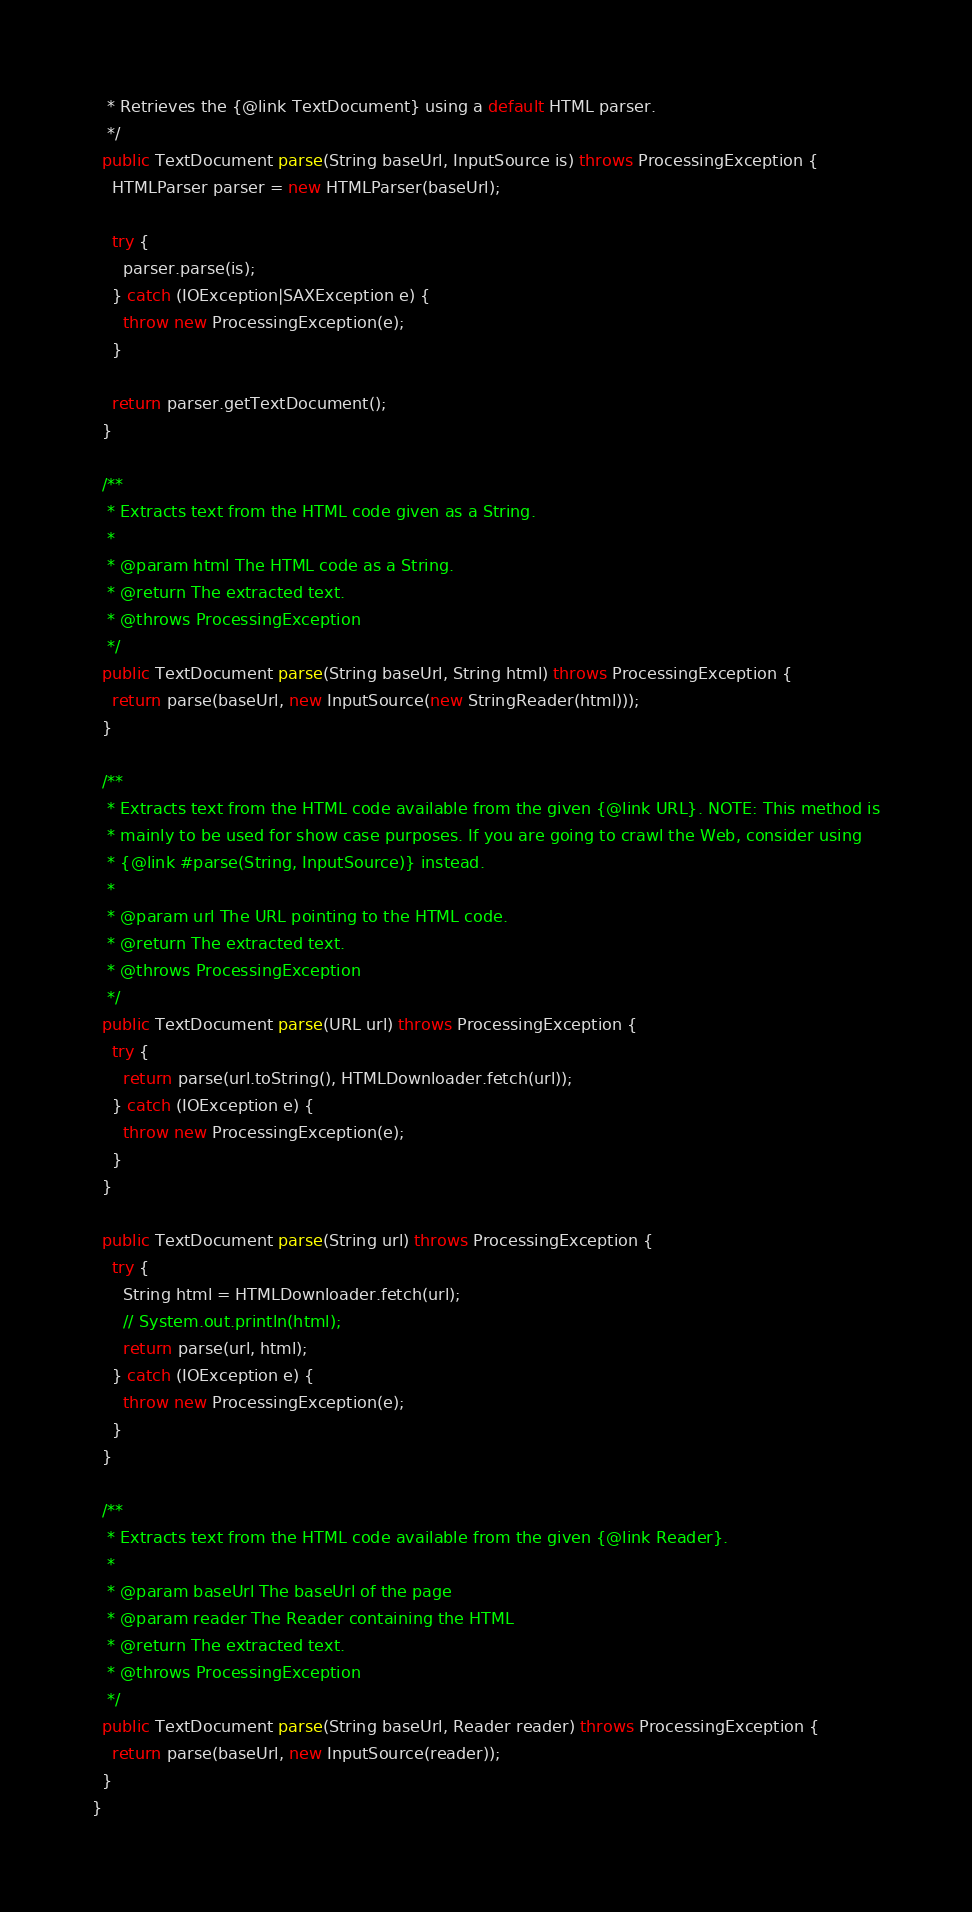<code> <loc_0><loc_0><loc_500><loc_500><_Java_>   * Retrieves the {@link TextDocument} using a default HTML parser.
   */
  public TextDocument parse(String baseUrl, InputSource is) throws ProcessingException {
    HTMLParser parser = new HTMLParser(baseUrl);

    try {
      parser.parse(is);
    } catch (IOException|SAXException e) {
      throw new ProcessingException(e);
    }

    return parser.getTextDocument();
  }

  /**
   * Extracts text from the HTML code given as a String.
   *
   * @param html The HTML code as a String.
   * @return The extracted text.
   * @throws ProcessingException
   */
  public TextDocument parse(String baseUrl, String html) throws ProcessingException {
    return parse(baseUrl, new InputSource(new StringReader(html)));
  }

  /**
   * Extracts text from the HTML code available from the given {@link URL}. NOTE: This method is
   * mainly to be used for show case purposes. If you are going to crawl the Web, consider using
   * {@link #parse(String, InputSource)} instead.
   *
   * @param url The URL pointing to the HTML code.
   * @return The extracted text.
   * @throws ProcessingException
   */
  public TextDocument parse(URL url) throws ProcessingException {
    try {
      return parse(url.toString(), HTMLDownloader.fetch(url));
    } catch (IOException e) {
      throw new ProcessingException(e);
    }
  }

  public TextDocument parse(String url) throws ProcessingException {
    try {
      String html = HTMLDownloader.fetch(url);
      // System.out.println(html);
      return parse(url, html);
    } catch (IOException e) {
      throw new ProcessingException(e);
    }
  }

  /**
   * Extracts text from the HTML code available from the given {@link Reader}.
   *
   * @param baseUrl The baseUrl of the page
   * @param reader The Reader containing the HTML
   * @return The extracted text.
   * @throws ProcessingException
   */
  public TextDocument parse(String baseUrl, Reader reader) throws ProcessingException {
    return parse(baseUrl, new InputSource(reader));
  }
}
</code> 